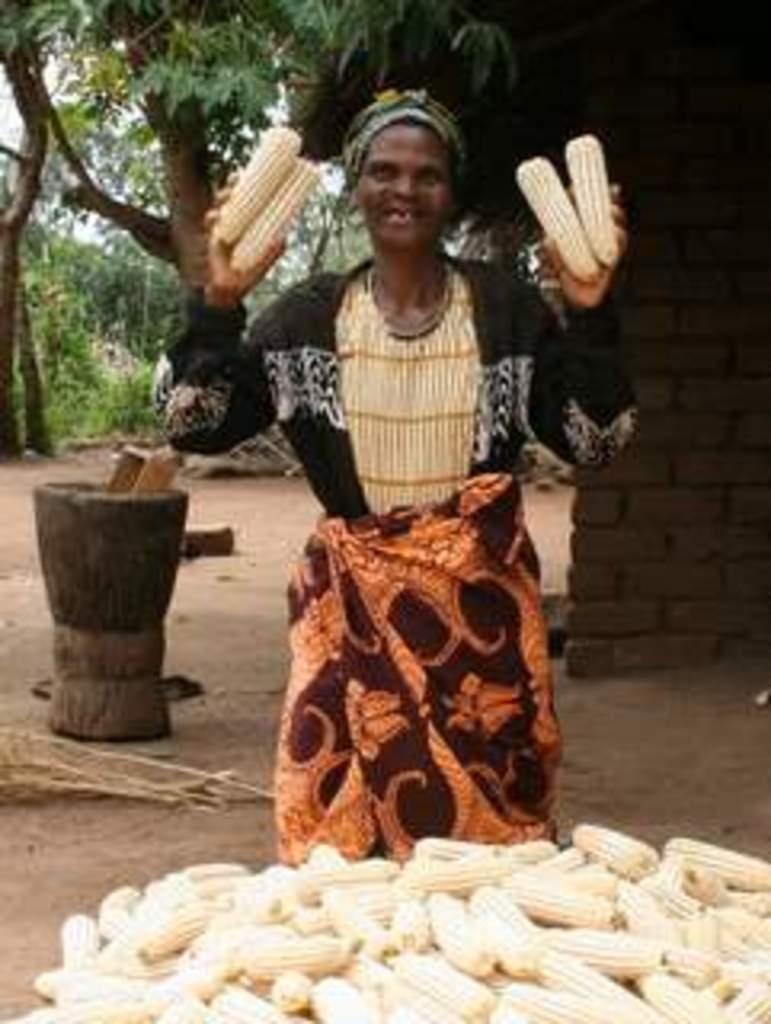Describe this image in one or two sentences. This picture is clicked outside. In the foreground we can see there are many number of corn placed on the ground. In the center there is a person smiling and holding corn and standing on the ground. In the background we can see there are some objects placed on the ground and we can see the sky, trees, plants and a brick wall. 